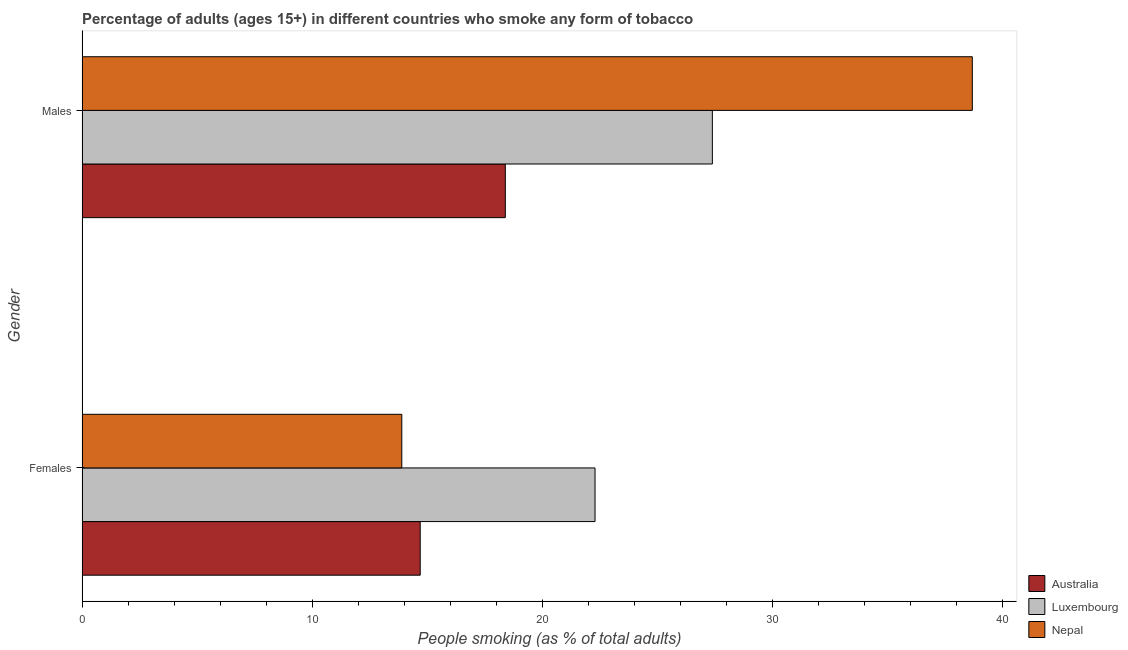How many different coloured bars are there?
Your answer should be very brief. 3. Are the number of bars on each tick of the Y-axis equal?
Keep it short and to the point. Yes. What is the label of the 1st group of bars from the top?
Keep it short and to the point. Males. What is the percentage of females who smoke in Australia?
Give a very brief answer. 14.7. Across all countries, what is the maximum percentage of females who smoke?
Provide a short and direct response. 22.3. In which country was the percentage of females who smoke maximum?
Your answer should be very brief. Luxembourg. In which country was the percentage of females who smoke minimum?
Your response must be concise. Nepal. What is the total percentage of females who smoke in the graph?
Offer a terse response. 50.9. What is the difference between the percentage of males who smoke in Australia and that in Luxembourg?
Make the answer very short. -9. What is the difference between the percentage of males who smoke in Luxembourg and the percentage of females who smoke in Australia?
Provide a succinct answer. 12.7. What is the average percentage of males who smoke per country?
Give a very brief answer. 28.17. What is the difference between the percentage of females who smoke and percentage of males who smoke in Australia?
Provide a short and direct response. -3.7. What is the ratio of the percentage of males who smoke in Luxembourg to that in Nepal?
Provide a succinct answer. 0.71. Is the percentage of females who smoke in Nepal less than that in Luxembourg?
Your answer should be very brief. Yes. What does the 3rd bar from the bottom in Females represents?
Your answer should be compact. Nepal. What is the difference between two consecutive major ticks on the X-axis?
Provide a short and direct response. 10. Are the values on the major ticks of X-axis written in scientific E-notation?
Provide a short and direct response. No. Does the graph contain any zero values?
Provide a short and direct response. No. Does the graph contain grids?
Ensure brevity in your answer.  No. How are the legend labels stacked?
Ensure brevity in your answer.  Vertical. What is the title of the graph?
Give a very brief answer. Percentage of adults (ages 15+) in different countries who smoke any form of tobacco. Does "Sub-Saharan Africa (all income levels)" appear as one of the legend labels in the graph?
Ensure brevity in your answer.  No. What is the label or title of the X-axis?
Your answer should be very brief. People smoking (as % of total adults). What is the People smoking (as % of total adults) in Luxembourg in Females?
Give a very brief answer. 22.3. What is the People smoking (as % of total adults) in Luxembourg in Males?
Your answer should be very brief. 27.4. What is the People smoking (as % of total adults) of Nepal in Males?
Provide a succinct answer. 38.7. Across all Gender, what is the maximum People smoking (as % of total adults) in Luxembourg?
Keep it short and to the point. 27.4. Across all Gender, what is the maximum People smoking (as % of total adults) in Nepal?
Your answer should be very brief. 38.7. Across all Gender, what is the minimum People smoking (as % of total adults) in Australia?
Your answer should be very brief. 14.7. Across all Gender, what is the minimum People smoking (as % of total adults) of Luxembourg?
Give a very brief answer. 22.3. What is the total People smoking (as % of total adults) of Australia in the graph?
Give a very brief answer. 33.1. What is the total People smoking (as % of total adults) of Luxembourg in the graph?
Offer a terse response. 49.7. What is the total People smoking (as % of total adults) of Nepal in the graph?
Offer a terse response. 52.6. What is the difference between the People smoking (as % of total adults) of Australia in Females and that in Males?
Make the answer very short. -3.7. What is the difference between the People smoking (as % of total adults) in Luxembourg in Females and that in Males?
Provide a succinct answer. -5.1. What is the difference between the People smoking (as % of total adults) in Nepal in Females and that in Males?
Make the answer very short. -24.8. What is the difference between the People smoking (as % of total adults) in Australia in Females and the People smoking (as % of total adults) in Luxembourg in Males?
Offer a terse response. -12.7. What is the difference between the People smoking (as % of total adults) in Luxembourg in Females and the People smoking (as % of total adults) in Nepal in Males?
Ensure brevity in your answer.  -16.4. What is the average People smoking (as % of total adults) of Australia per Gender?
Your answer should be compact. 16.55. What is the average People smoking (as % of total adults) in Luxembourg per Gender?
Your answer should be compact. 24.85. What is the average People smoking (as % of total adults) in Nepal per Gender?
Your response must be concise. 26.3. What is the difference between the People smoking (as % of total adults) in Luxembourg and People smoking (as % of total adults) in Nepal in Females?
Provide a succinct answer. 8.4. What is the difference between the People smoking (as % of total adults) of Australia and People smoking (as % of total adults) of Nepal in Males?
Your response must be concise. -20.3. What is the difference between the People smoking (as % of total adults) in Luxembourg and People smoking (as % of total adults) in Nepal in Males?
Your response must be concise. -11.3. What is the ratio of the People smoking (as % of total adults) of Australia in Females to that in Males?
Keep it short and to the point. 0.8. What is the ratio of the People smoking (as % of total adults) of Luxembourg in Females to that in Males?
Make the answer very short. 0.81. What is the ratio of the People smoking (as % of total adults) of Nepal in Females to that in Males?
Make the answer very short. 0.36. What is the difference between the highest and the second highest People smoking (as % of total adults) of Australia?
Make the answer very short. 3.7. What is the difference between the highest and the second highest People smoking (as % of total adults) in Luxembourg?
Provide a succinct answer. 5.1. What is the difference between the highest and the second highest People smoking (as % of total adults) of Nepal?
Your response must be concise. 24.8. What is the difference between the highest and the lowest People smoking (as % of total adults) in Australia?
Provide a short and direct response. 3.7. What is the difference between the highest and the lowest People smoking (as % of total adults) of Nepal?
Provide a short and direct response. 24.8. 